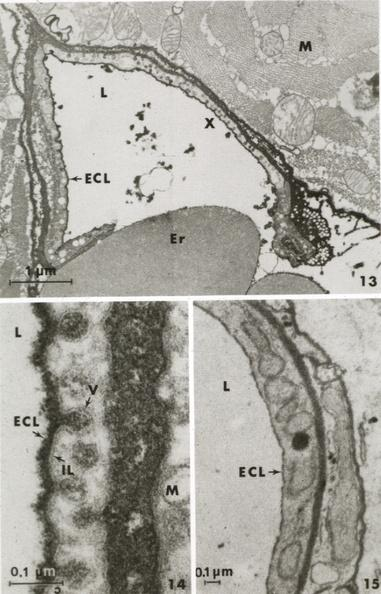what is present?
Answer the question using a single word or phrase. Capillary 